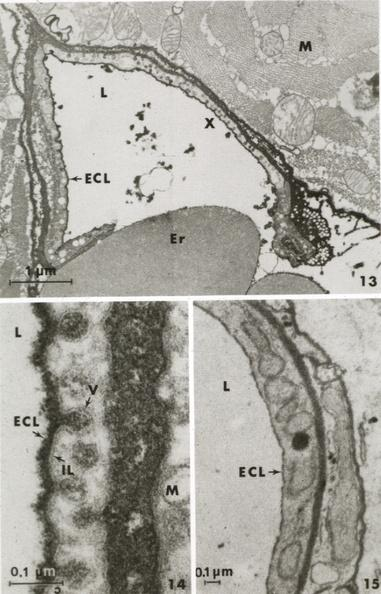what is present?
Answer the question using a single word or phrase. Capillary 